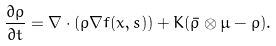Convert formula to latex. <formula><loc_0><loc_0><loc_500><loc_500>\frac { \partial \rho } { \partial t } = \nabla \cdot ( \rho \nabla f ( x , s ) ) + K ( \bar { \rho } \otimes \mu - \rho ) .</formula> 